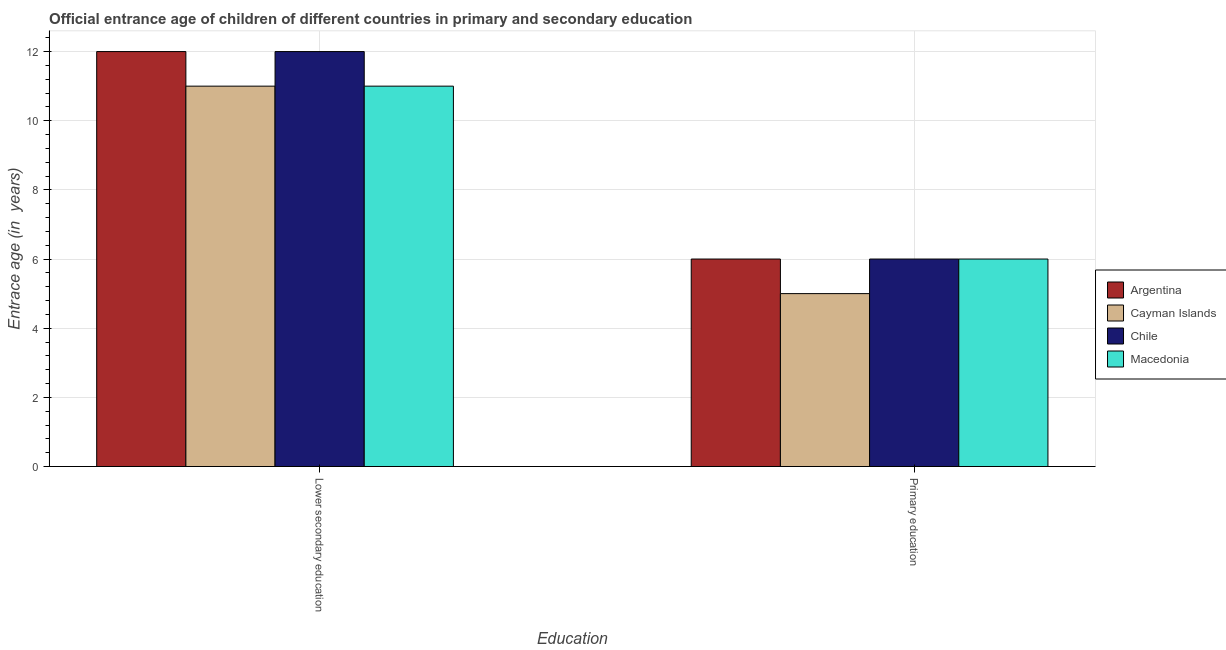How many groups of bars are there?
Your response must be concise. 2. Are the number of bars per tick equal to the number of legend labels?
Your answer should be very brief. Yes. Are the number of bars on each tick of the X-axis equal?
Offer a terse response. Yes. How many bars are there on the 1st tick from the left?
Your answer should be compact. 4. How many bars are there on the 2nd tick from the right?
Offer a very short reply. 4. What is the label of the 1st group of bars from the left?
Ensure brevity in your answer.  Lower secondary education. What is the entrance age of chiildren in primary education in Chile?
Your response must be concise. 6. Across all countries, what is the maximum entrance age of children in lower secondary education?
Your response must be concise. 12. Across all countries, what is the minimum entrance age of children in lower secondary education?
Your answer should be compact. 11. In which country was the entrance age of children in lower secondary education minimum?
Offer a very short reply. Cayman Islands. What is the total entrance age of chiildren in primary education in the graph?
Your answer should be compact. 23. What is the difference between the entrance age of children in lower secondary education in Chile and the entrance age of chiildren in primary education in Argentina?
Keep it short and to the point. 6. What is the average entrance age of chiildren in primary education per country?
Provide a succinct answer. 5.75. What is the difference between the entrance age of children in lower secondary education and entrance age of chiildren in primary education in Cayman Islands?
Give a very brief answer. 6. What does the 1st bar from the left in Primary education represents?
Keep it short and to the point. Argentina. What does the 3rd bar from the right in Lower secondary education represents?
Your answer should be very brief. Cayman Islands. How many bars are there?
Offer a very short reply. 8. How many countries are there in the graph?
Ensure brevity in your answer.  4. Are the values on the major ticks of Y-axis written in scientific E-notation?
Ensure brevity in your answer.  No. Does the graph contain any zero values?
Provide a short and direct response. No. Does the graph contain grids?
Provide a short and direct response. Yes. Where does the legend appear in the graph?
Your answer should be very brief. Center right. What is the title of the graph?
Provide a short and direct response. Official entrance age of children of different countries in primary and secondary education. What is the label or title of the X-axis?
Your answer should be very brief. Education. What is the label or title of the Y-axis?
Offer a terse response. Entrace age (in  years). What is the Entrace age (in  years) of Cayman Islands in Lower secondary education?
Your answer should be compact. 11. What is the Entrace age (in  years) in Cayman Islands in Primary education?
Your answer should be very brief. 5. What is the Entrace age (in  years) of Chile in Primary education?
Your answer should be very brief. 6. What is the Entrace age (in  years) of Macedonia in Primary education?
Offer a very short reply. 6. Across all Education, what is the maximum Entrace age (in  years) in Argentina?
Provide a short and direct response. 12. Across all Education, what is the maximum Entrace age (in  years) of Cayman Islands?
Offer a very short reply. 11. Across all Education, what is the maximum Entrace age (in  years) of Chile?
Offer a very short reply. 12. Across all Education, what is the maximum Entrace age (in  years) of Macedonia?
Make the answer very short. 11. Across all Education, what is the minimum Entrace age (in  years) in Argentina?
Keep it short and to the point. 6. Across all Education, what is the minimum Entrace age (in  years) of Cayman Islands?
Your answer should be very brief. 5. What is the total Entrace age (in  years) of Cayman Islands in the graph?
Provide a succinct answer. 16. What is the total Entrace age (in  years) of Macedonia in the graph?
Give a very brief answer. 17. What is the difference between the Entrace age (in  years) in Chile in Lower secondary education and that in Primary education?
Provide a succinct answer. 6. What is the difference between the Entrace age (in  years) of Chile in Lower secondary education and the Entrace age (in  years) of Macedonia in Primary education?
Provide a succinct answer. 6. What is the average Entrace age (in  years) in Cayman Islands per Education?
Your answer should be compact. 8. What is the average Entrace age (in  years) in Macedonia per Education?
Ensure brevity in your answer.  8.5. What is the difference between the Entrace age (in  years) in Argentina and Entrace age (in  years) in Cayman Islands in Lower secondary education?
Your answer should be compact. 1. What is the difference between the Entrace age (in  years) in Argentina and Entrace age (in  years) in Chile in Lower secondary education?
Offer a very short reply. 0. What is the difference between the Entrace age (in  years) of Argentina and Entrace age (in  years) of Macedonia in Lower secondary education?
Offer a terse response. 1. What is the difference between the Entrace age (in  years) in Chile and Entrace age (in  years) in Macedonia in Lower secondary education?
Provide a short and direct response. 1. What is the difference between the Entrace age (in  years) in Argentina and Entrace age (in  years) in Cayman Islands in Primary education?
Your answer should be very brief. 1. What is the difference between the Entrace age (in  years) in Argentina and Entrace age (in  years) in Chile in Primary education?
Offer a terse response. 0. What is the difference between the Entrace age (in  years) of Argentina and Entrace age (in  years) of Macedonia in Primary education?
Make the answer very short. 0. What is the difference between the Entrace age (in  years) of Chile and Entrace age (in  years) of Macedonia in Primary education?
Your answer should be very brief. 0. What is the ratio of the Entrace age (in  years) in Cayman Islands in Lower secondary education to that in Primary education?
Your answer should be very brief. 2.2. What is the ratio of the Entrace age (in  years) of Macedonia in Lower secondary education to that in Primary education?
Make the answer very short. 1.83. What is the difference between the highest and the second highest Entrace age (in  years) of Argentina?
Offer a terse response. 6. What is the difference between the highest and the second highest Entrace age (in  years) of Cayman Islands?
Your answer should be compact. 6. What is the difference between the highest and the lowest Entrace age (in  years) in Argentina?
Offer a very short reply. 6. What is the difference between the highest and the lowest Entrace age (in  years) in Chile?
Your response must be concise. 6. 